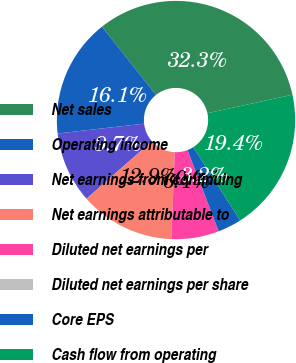Convert chart to OTSL. <chart><loc_0><loc_0><loc_500><loc_500><pie_chart><fcel>Net sales<fcel>Operating income<fcel>Net earnings from continuing<fcel>Net earnings attributable to<fcel>Diluted net earnings per<fcel>Diluted net earnings per share<fcel>Core EPS<fcel>Cash flow from operating<nl><fcel>32.26%<fcel>16.13%<fcel>9.68%<fcel>12.9%<fcel>6.45%<fcel>0.0%<fcel>3.23%<fcel>19.35%<nl></chart> 